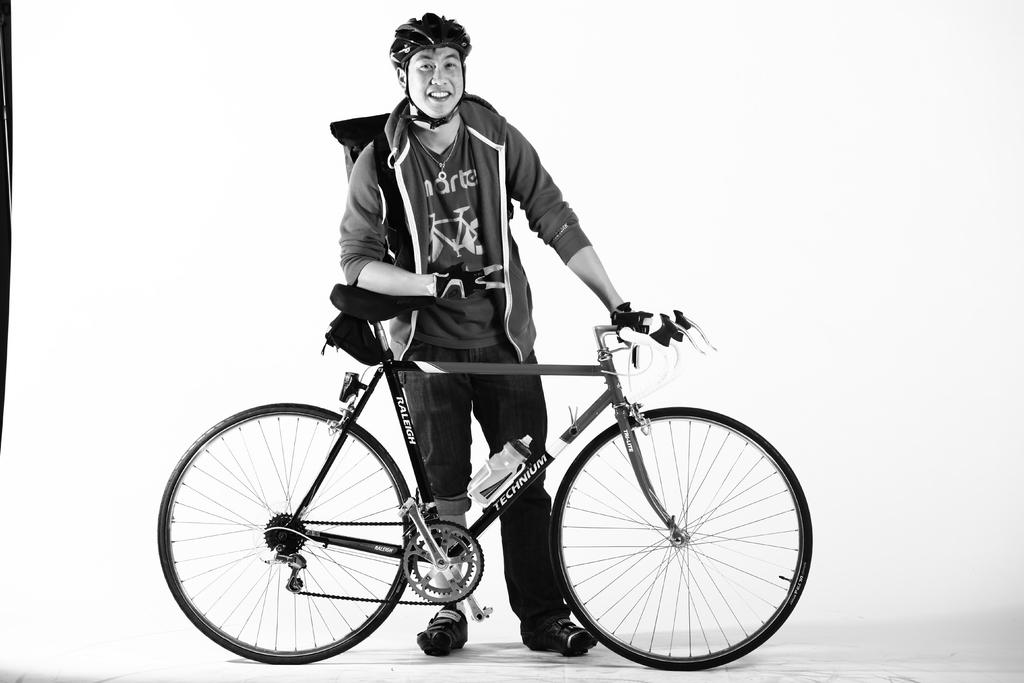What is the color scheme of the image? The image is black and white. What can be seen in the foreground of the image? There is a man standing in the image. What is the man holding in the image? The man is holding a bicycle. Can you describe any additional features of the bicycle? There is a water bottle fixed to the bicycle. What is the color of the background in the image? The background of the image appears white in color. What type of tramp is visible in the image? There is no tramp present in the image; it features a man holding a bicycle. Can you tell me which elbow the man is using to hold the bicycle? There is no mention of the man's elbows in the image, as it only shows him holding the bicycle with his hands. 